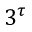Convert formula to latex. <formula><loc_0><loc_0><loc_500><loc_500>3 ^ { \tau }</formula> 